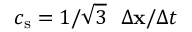Convert formula to latex. <formula><loc_0><loc_0><loc_500><loc_500>c _ { s } = 1 / \sqrt { 3 } \quad D e l t a x / \Delta t</formula> 